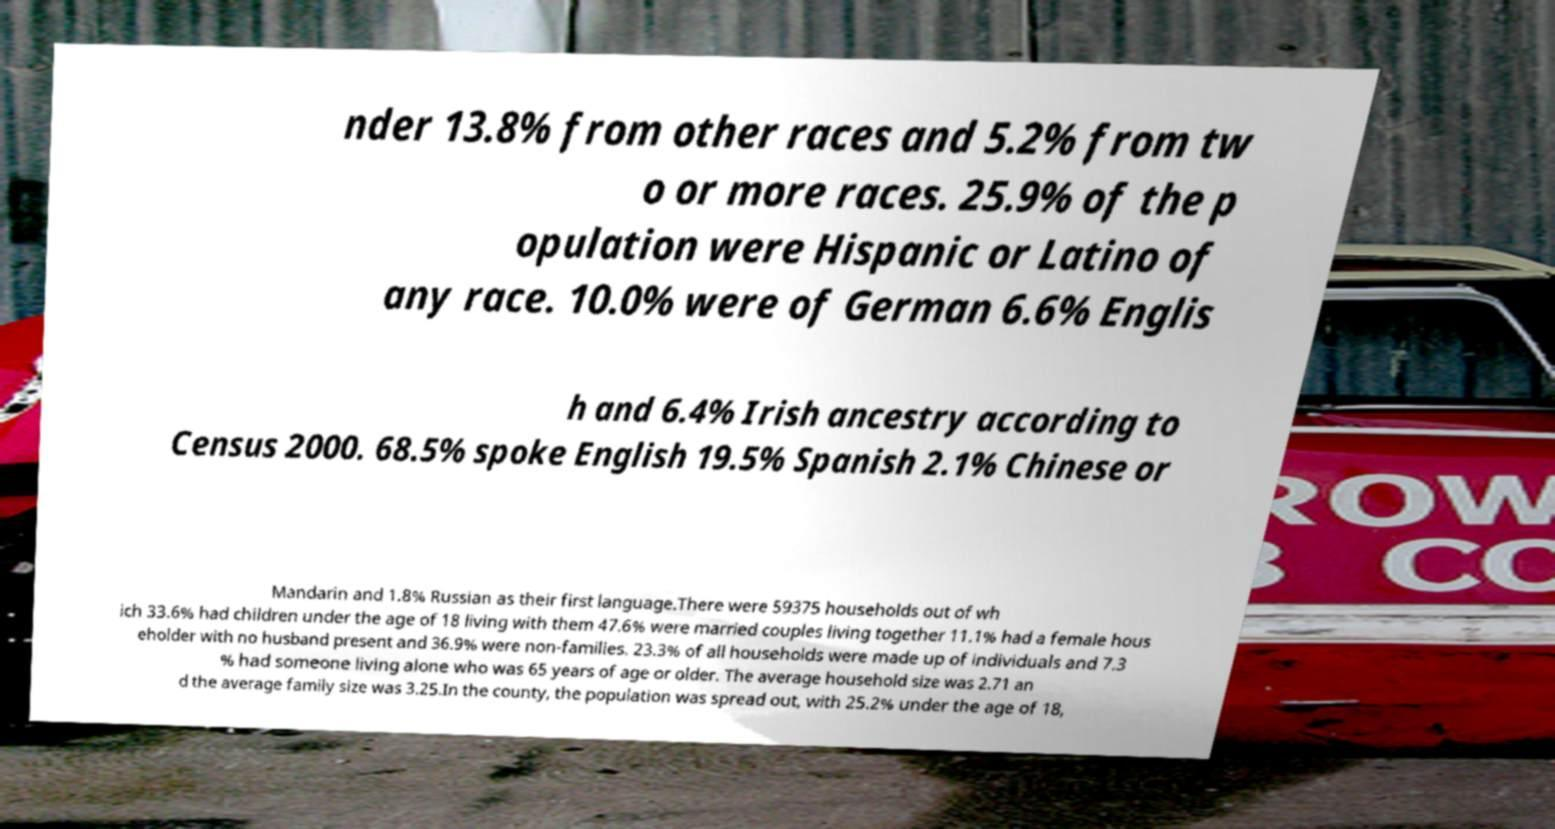There's text embedded in this image that I need extracted. Can you transcribe it verbatim? nder 13.8% from other races and 5.2% from tw o or more races. 25.9% of the p opulation were Hispanic or Latino of any race. 10.0% were of German 6.6% Englis h and 6.4% Irish ancestry according to Census 2000. 68.5% spoke English 19.5% Spanish 2.1% Chinese or Mandarin and 1.8% Russian as their first language.There were 59375 households out of wh ich 33.6% had children under the age of 18 living with them 47.6% were married couples living together 11.1% had a female hous eholder with no husband present and 36.9% were non-families. 23.3% of all households were made up of individuals and 7.3 % had someone living alone who was 65 years of age or older. The average household size was 2.71 an d the average family size was 3.25.In the county, the population was spread out, with 25.2% under the age of 18, 